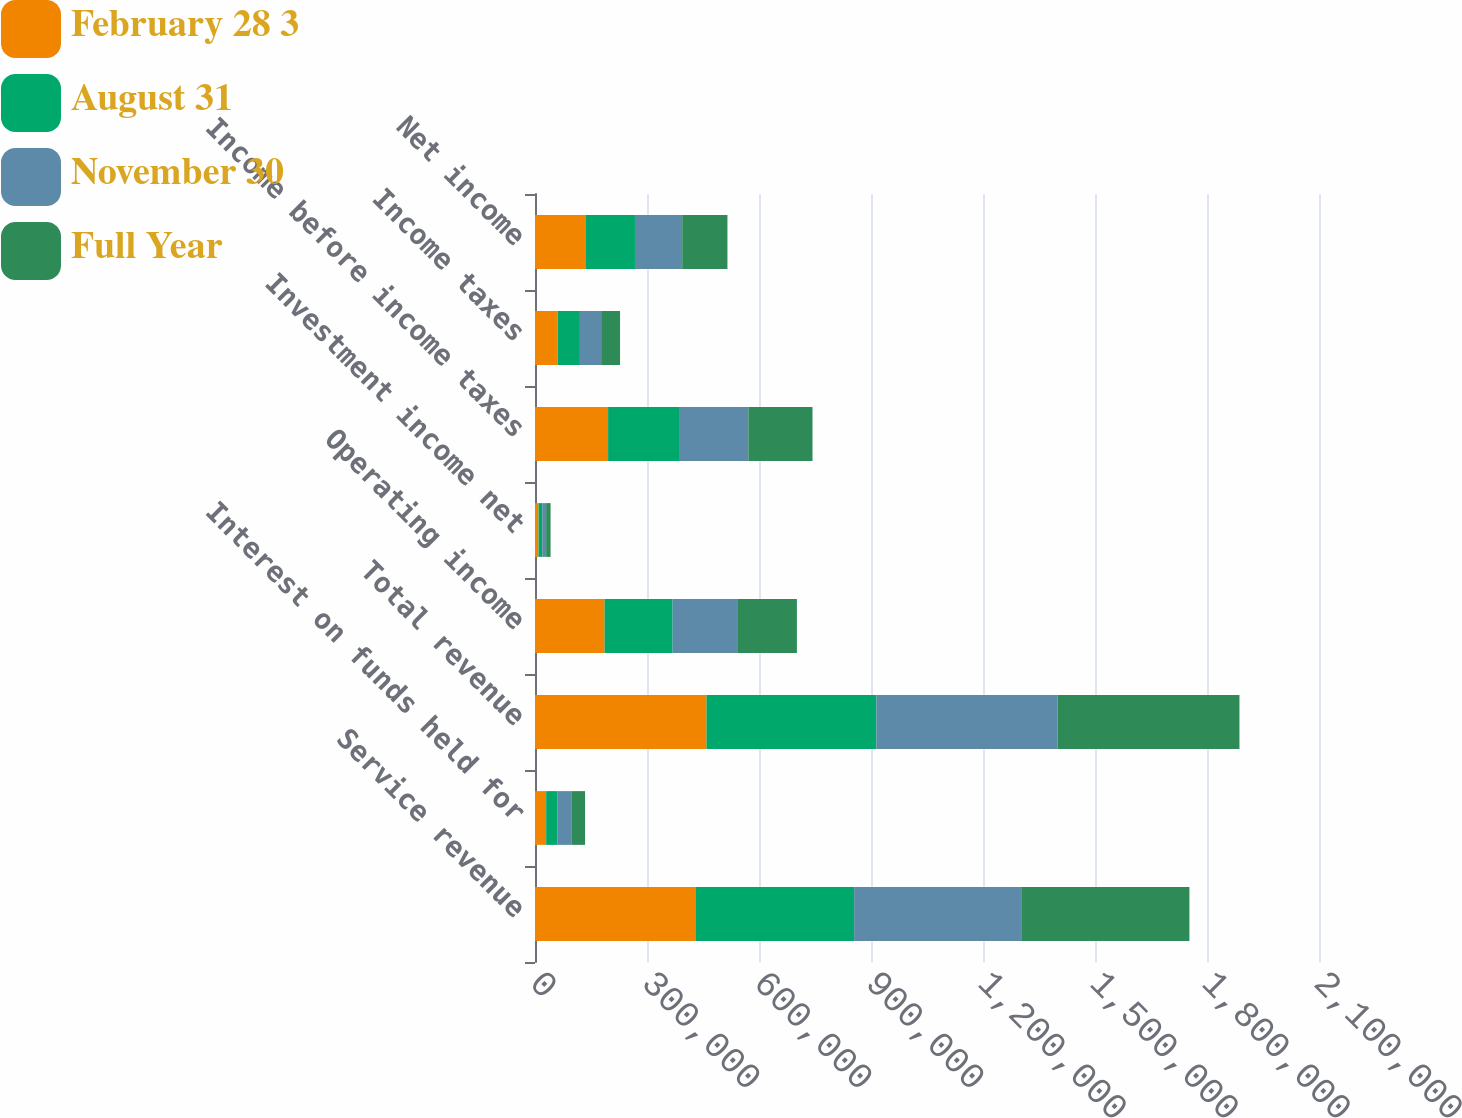<chart> <loc_0><loc_0><loc_500><loc_500><stacked_bar_chart><ecel><fcel>Service revenue<fcel>Interest on funds held for<fcel>Total revenue<fcel>Operating income<fcel>Investment income net<fcel>Income before income taxes<fcel>Income taxes<fcel>Net income<nl><fcel>February 28 3<fcel>429543<fcel>29831<fcel>459374<fcel>186354<fcel>9416<fcel>195770<fcel>60689<fcel>135081<nl><fcel>August 31<fcel>425246<fcel>29709<fcel>454955<fcel>182328<fcel>9941<fcel>192269<fcel>59603<fcel>132666<nl><fcel>November 30<fcel>447568<fcel>37719<fcel>485287<fcel>172984<fcel>10494<fcel>183478<fcel>56878<fcel>126600<nl><fcel>Full Year<fcel>450511<fcel>36837<fcel>487348<fcel>159882<fcel>11870<fcel>171752<fcel>50652<fcel>121100<nl></chart> 